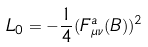<formula> <loc_0><loc_0><loc_500><loc_500>L _ { 0 } = - \frac { 1 } { 4 } ( F ^ { a } _ { \mu \nu } ( B ) ) ^ { 2 }</formula> 